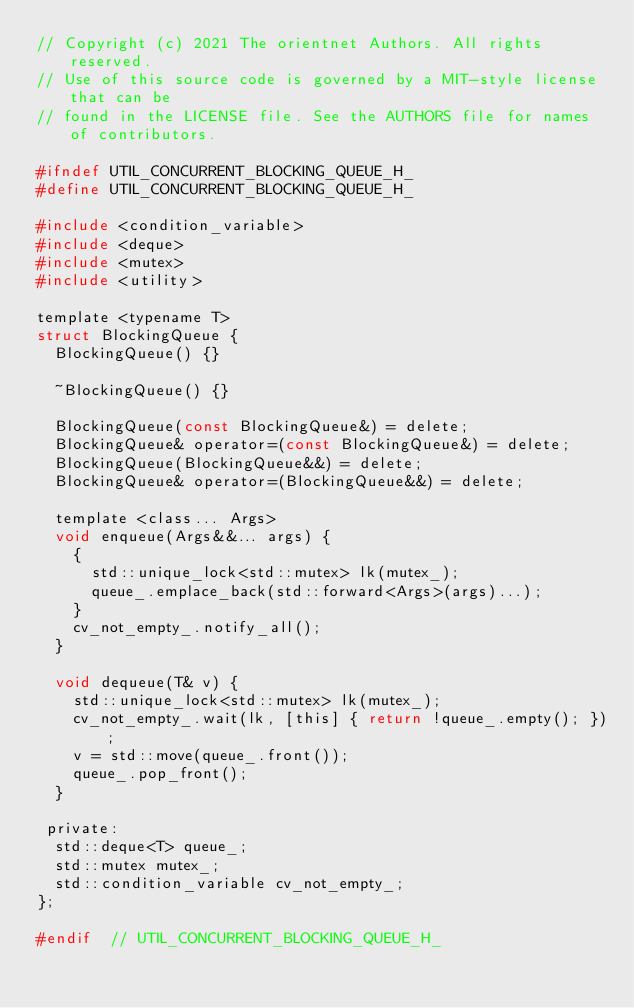<code> <loc_0><loc_0><loc_500><loc_500><_C_>// Copyright (c) 2021 The orientnet Authors. All rights reserved.
// Use of this source code is governed by a MIT-style license that can be
// found in the LICENSE file. See the AUTHORS file for names of contributors.

#ifndef UTIL_CONCURRENT_BLOCKING_QUEUE_H_
#define UTIL_CONCURRENT_BLOCKING_QUEUE_H_

#include <condition_variable>
#include <deque>
#include <mutex>
#include <utility>

template <typename T>
struct BlockingQueue {
  BlockingQueue() {}

  ~BlockingQueue() {}

  BlockingQueue(const BlockingQueue&) = delete;
  BlockingQueue& operator=(const BlockingQueue&) = delete;
  BlockingQueue(BlockingQueue&&) = delete;
  BlockingQueue& operator=(BlockingQueue&&) = delete;

  template <class... Args>
  void enqueue(Args&&... args) {
    {
      std::unique_lock<std::mutex> lk(mutex_);
      queue_.emplace_back(std::forward<Args>(args)...);
    }
    cv_not_empty_.notify_all();
  }

  void dequeue(T& v) {
    std::unique_lock<std::mutex> lk(mutex_);
    cv_not_empty_.wait(lk, [this] { return !queue_.empty(); });
    v = std::move(queue_.front());
    queue_.pop_front();
  }

 private:
  std::deque<T> queue_;
  std::mutex mutex_;
  std::condition_variable cv_not_empty_;
};

#endif  // UTIL_CONCURRENT_BLOCKING_QUEUE_H_
</code> 